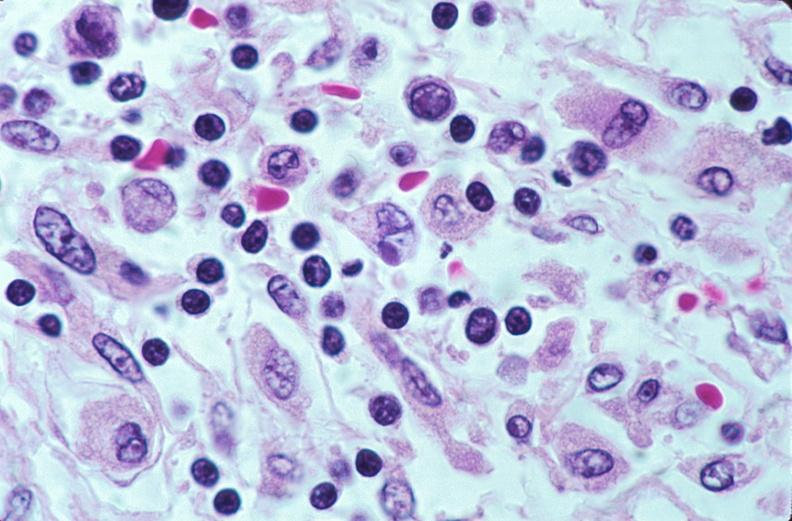does this image show lymph nodes, nodular sclerosing hodgkins disease?
Answer the question using a single word or phrase. Yes 